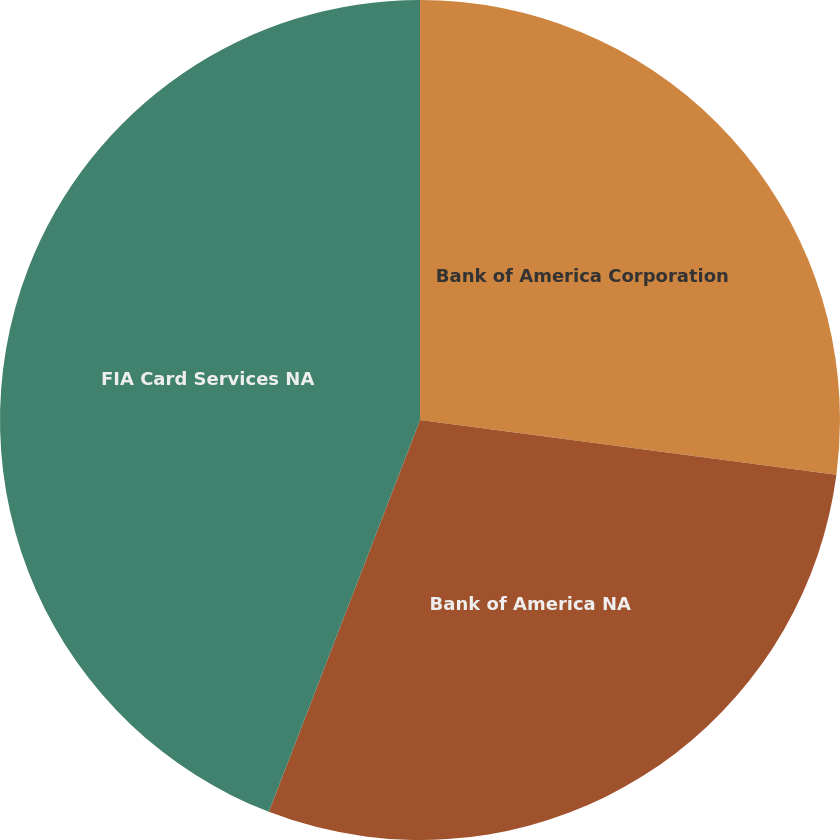Convert chart to OTSL. <chart><loc_0><loc_0><loc_500><loc_500><pie_chart><fcel>Bank of America Corporation<fcel>Bank of America NA<fcel>FIA Card Services NA<nl><fcel>27.08%<fcel>28.78%<fcel>44.14%<nl></chart> 